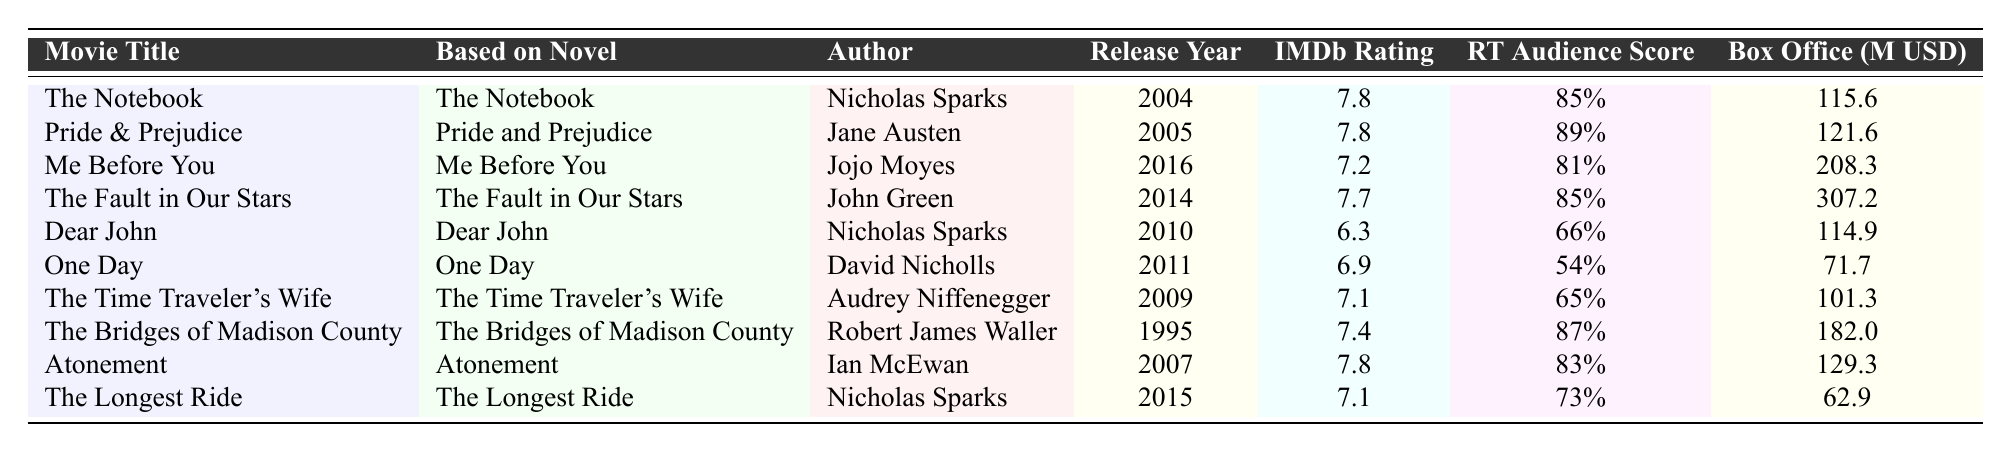What is the IMDb rating for "Pride & Prejudice"? The IMDb rating for "Pride & Prejudice" is listed directly in the table as 7.8.
Answer: 7.8 Which film based on a Nicholas Sparks novel has the highest box office earnings? "The Fault in Our Stars" has the highest box office earnings at 307.2 million USD, which can be compared against the other box office figures in the table.
Answer: The Fault in Our Stars What is the Rotten Tomatoes Audience Score for "Me Before You"? The table shows that the Rotten Tomatoes Audience Score for "Me Before You" is 81%.
Answer: 81% How many movies in the table have an IMDb rating of 7.8? The movies with an IMDb rating of 7.8 are "The Notebook," "Pride & Prejudice," and "Atonement," adding to a total of three movies.
Answer: 3 Is "The Longest Ride" rated higher than "Dear John"? "The Longest Ride" has an IMDb rating of 7.1, while "Dear John" has a rating of 6.3, so yes, it is rated higher.
Answer: Yes What is the average box office earnings of the movies released in 2015? "The Longest Ride" is the only film from 2015 with box office earnings of 62.9 million USD, so the average is simply 62.9 million USD.
Answer: 62.9 million USD Which author, based on the table, appears most frequently for adaptations? Nicholas Sparks appears three times in the table for "The Notebook," "Dear John," and "The Longest Ride," making him the most frequent author.
Answer: Nicholas Sparks What is the difference between the Rotten Tomatoes Audience Scores of "The Fault in Our Stars" and "One Day"? "The Fault in Our Stars" scores 85%, while "One Day" scores 54%. The difference is 85 - 54 = 31.
Answer: 31 Which movie has the lowest IMDb rating and what is it? The lowest IMDb rating is 6.3 for "Dear John," which is clearly indicated in the table under the IMDb Rating column.
Answer: Dear John Are there any movies released before 2000 in the table? All listed movies in the table were released between 1995 and 2016, so "The Bridges of Madison County" is the only one before 2000.
Answer: Yes, The Bridges of Madison County 